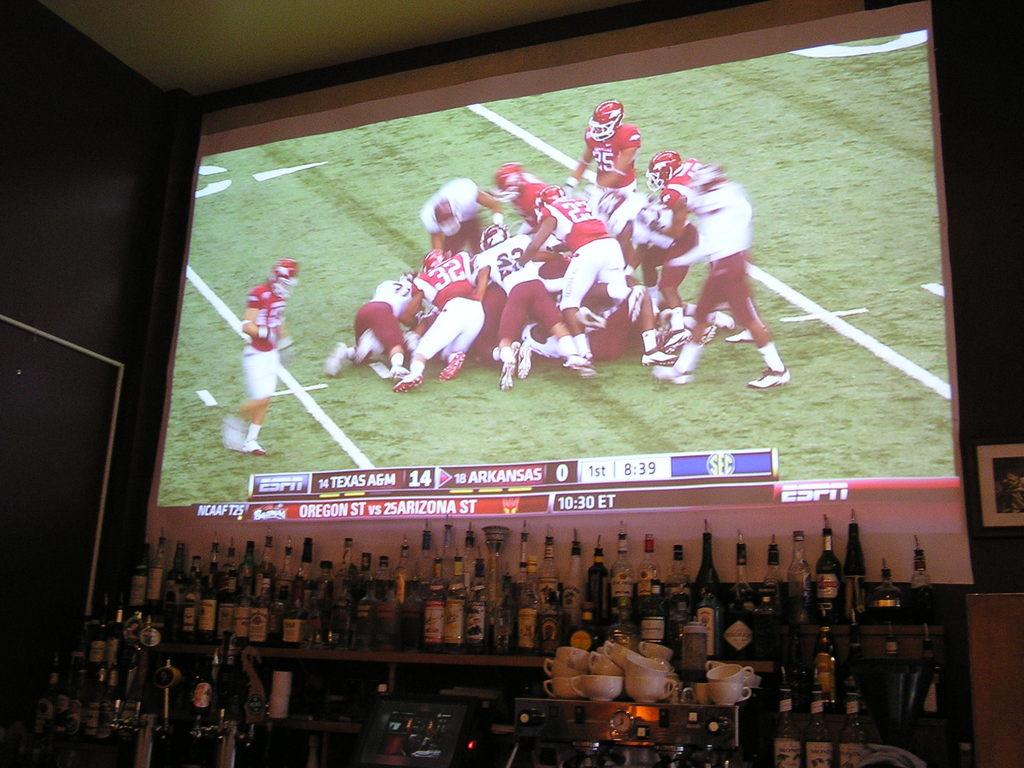Who is playing in the game?
Your answer should be very brief. Texas a&m and arkansas. 